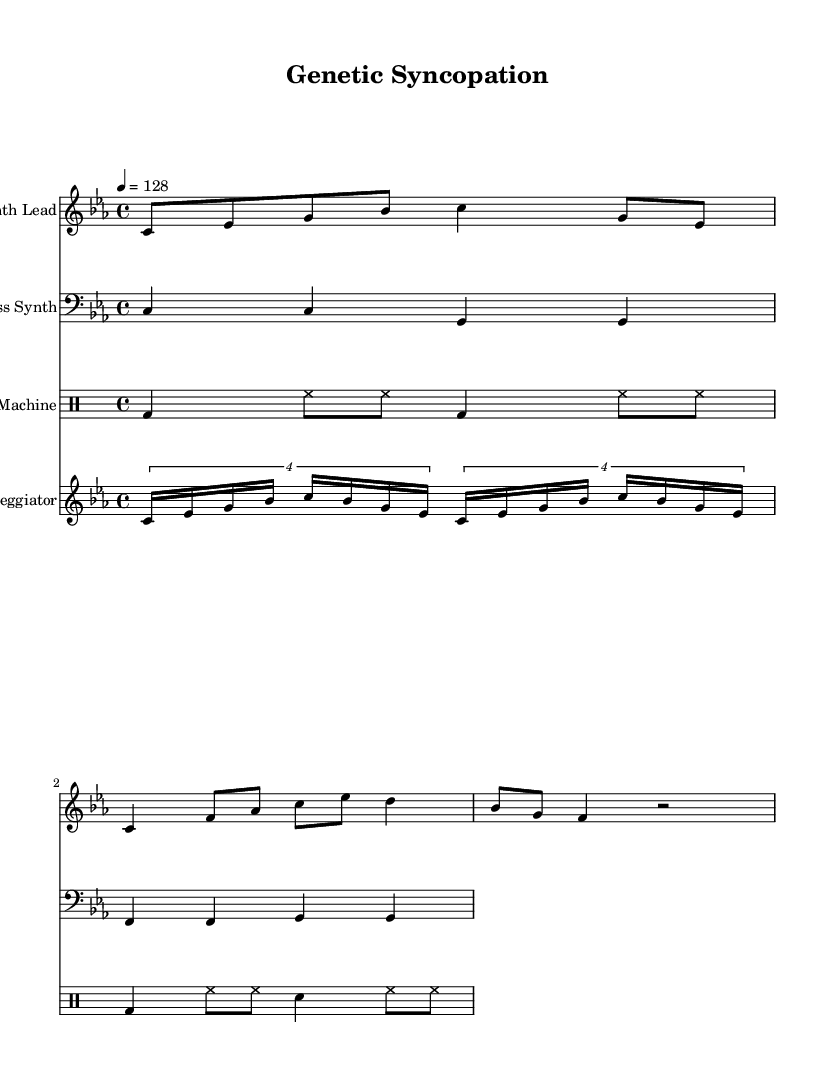What is the key signature of this music? The key signature is C minor, which has three flats (B flat, E flat, and A flat). It is indicated at the beginning of the staff.
Answer: C minor What is the time signature of this music? The time signature is located at the beginning of the score, shown as 4/4, which means there are four beats in each measure.
Answer: 4/4 What is the tempo marking of this piece? The tempo marking is specified in beats per minute and is indicated as 4 = 128, meaning there are 128 beats per minute.
Answer: 128 How many measures are present in the Synth Lead? The Synth Lead consists of 6 measures, as counted by the distinct groupings of notes separated by the vertical lines on the staff.
Answer: 6 Which instruments are included in this score? The score includes a Synth Lead, Bass Synth, Drum Machine, and an Arpeggiator, each indicated by their respective instrument names at the start of each staff.
Answer: Synth Lead, Bass Synth, Drum Machine, Arpeggiator How does the bass synth mainly move in this piece? The bass synth uses a repetitive pattern involving quarter notes primarily, moving through C and F notes, which creates a driving pulse typical in dance music.
Answer: Repetitive quarter notes What rhythmic style is associated with the drum machine in this score? The drum machine showcases a typical dance music pattern with kick drums on the downbeats and hi-hats filling the upbeats, creating a steady, danceable groove.
Answer: Danceable groove 